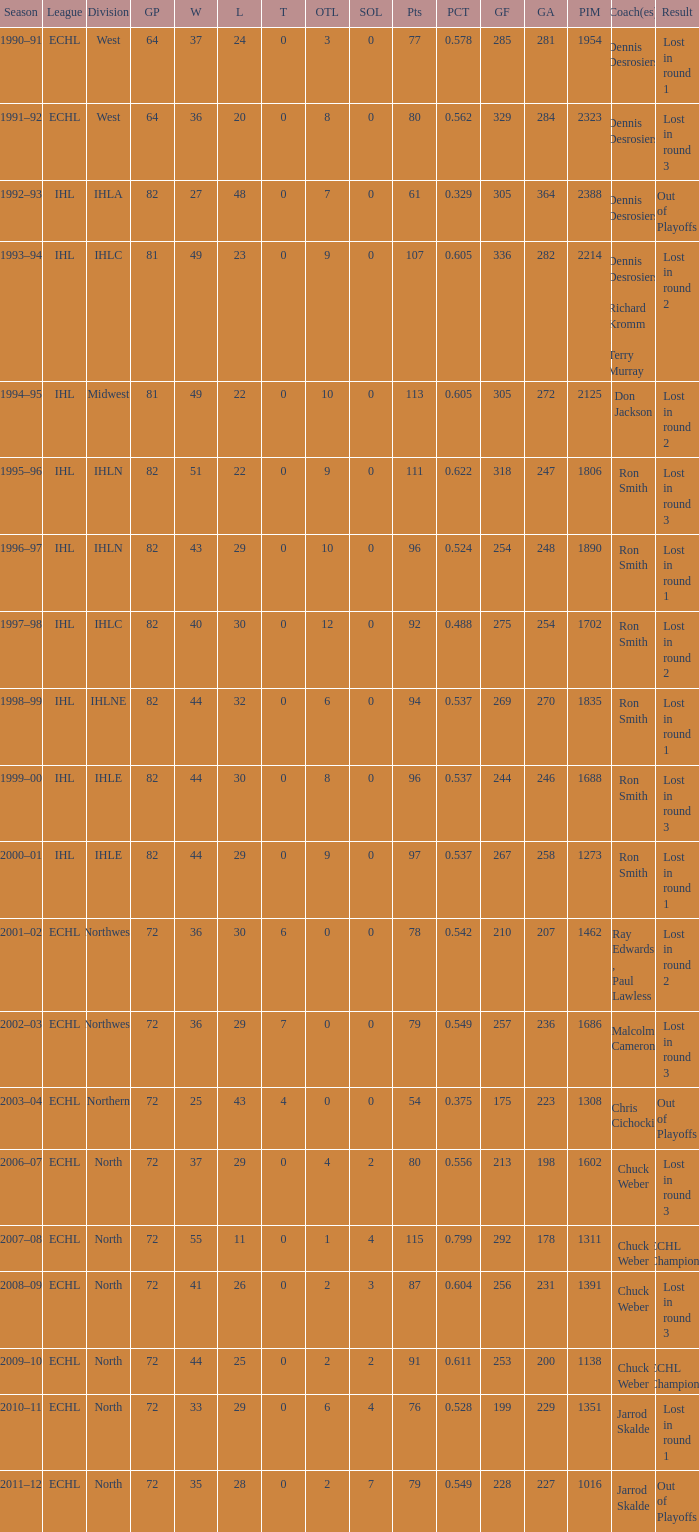In which season did the team achieve a gp of 244? 1999–00. 